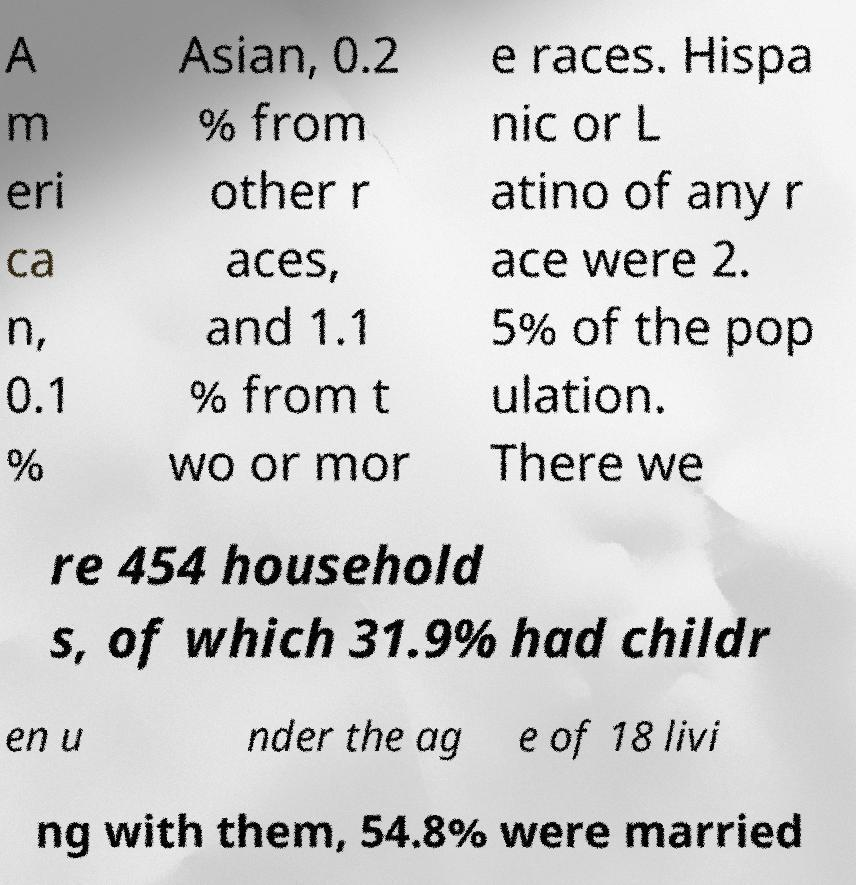Could you extract and type out the text from this image? A m eri ca n, 0.1 % Asian, 0.2 % from other r aces, and 1.1 % from t wo or mor e races. Hispa nic or L atino of any r ace were 2. 5% of the pop ulation. There we re 454 household s, of which 31.9% had childr en u nder the ag e of 18 livi ng with them, 54.8% were married 